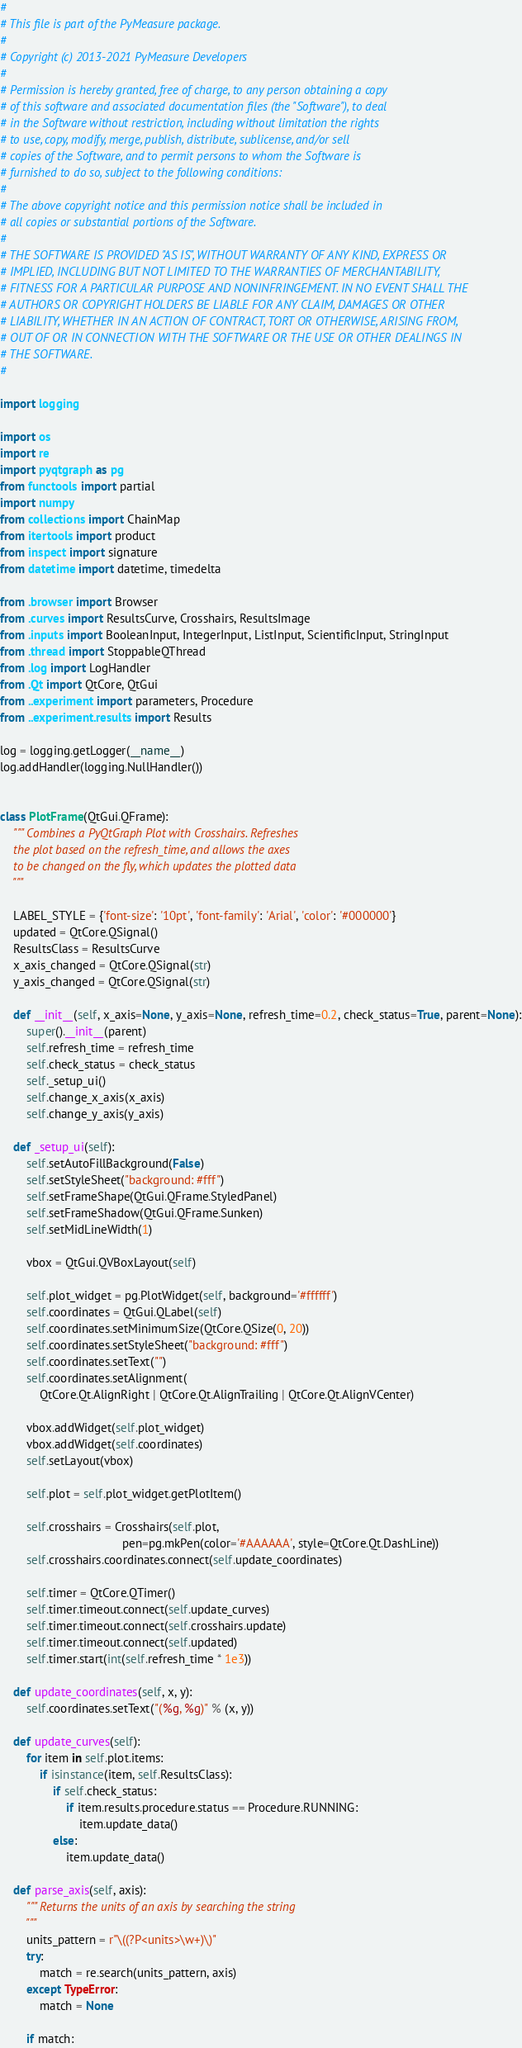Convert code to text. <code><loc_0><loc_0><loc_500><loc_500><_Python_>#
# This file is part of the PyMeasure package.
#
# Copyright (c) 2013-2021 PyMeasure Developers
#
# Permission is hereby granted, free of charge, to any person obtaining a copy
# of this software and associated documentation files (the "Software"), to deal
# in the Software without restriction, including without limitation the rights
# to use, copy, modify, merge, publish, distribute, sublicense, and/or sell
# copies of the Software, and to permit persons to whom the Software is
# furnished to do so, subject to the following conditions:
#
# The above copyright notice and this permission notice shall be included in
# all copies or substantial portions of the Software.
#
# THE SOFTWARE IS PROVIDED "AS IS", WITHOUT WARRANTY OF ANY KIND, EXPRESS OR
# IMPLIED, INCLUDING BUT NOT LIMITED TO THE WARRANTIES OF MERCHANTABILITY,
# FITNESS FOR A PARTICULAR PURPOSE AND NONINFRINGEMENT. IN NO EVENT SHALL THE
# AUTHORS OR COPYRIGHT HOLDERS BE LIABLE FOR ANY CLAIM, DAMAGES OR OTHER
# LIABILITY, WHETHER IN AN ACTION OF CONTRACT, TORT OR OTHERWISE, ARISING FROM,
# OUT OF OR IN CONNECTION WITH THE SOFTWARE OR THE USE OR OTHER DEALINGS IN
# THE SOFTWARE.
#

import logging

import os
import re
import pyqtgraph as pg
from functools import partial
import numpy
from collections import ChainMap
from itertools import product
from inspect import signature
from datetime import datetime, timedelta

from .browser import Browser
from .curves import ResultsCurve, Crosshairs, ResultsImage
from .inputs import BooleanInput, IntegerInput, ListInput, ScientificInput, StringInput
from .thread import StoppableQThread
from .log import LogHandler
from .Qt import QtCore, QtGui
from ..experiment import parameters, Procedure
from ..experiment.results import Results

log = logging.getLogger(__name__)
log.addHandler(logging.NullHandler())


class PlotFrame(QtGui.QFrame):
    """ Combines a PyQtGraph Plot with Crosshairs. Refreshes
    the plot based on the refresh_time, and allows the axes
    to be changed on the fly, which updates the plotted data
    """

    LABEL_STYLE = {'font-size': '10pt', 'font-family': 'Arial', 'color': '#000000'}
    updated = QtCore.QSignal()
    ResultsClass = ResultsCurve
    x_axis_changed = QtCore.QSignal(str)
    y_axis_changed = QtCore.QSignal(str)

    def __init__(self, x_axis=None, y_axis=None, refresh_time=0.2, check_status=True, parent=None):
        super().__init__(parent)
        self.refresh_time = refresh_time
        self.check_status = check_status
        self._setup_ui()
        self.change_x_axis(x_axis)
        self.change_y_axis(y_axis)

    def _setup_ui(self):
        self.setAutoFillBackground(False)
        self.setStyleSheet("background: #fff")
        self.setFrameShape(QtGui.QFrame.StyledPanel)
        self.setFrameShadow(QtGui.QFrame.Sunken)
        self.setMidLineWidth(1)

        vbox = QtGui.QVBoxLayout(self)

        self.plot_widget = pg.PlotWidget(self, background='#ffffff')
        self.coordinates = QtGui.QLabel(self)
        self.coordinates.setMinimumSize(QtCore.QSize(0, 20))
        self.coordinates.setStyleSheet("background: #fff")
        self.coordinates.setText("")
        self.coordinates.setAlignment(
            QtCore.Qt.AlignRight | QtCore.Qt.AlignTrailing | QtCore.Qt.AlignVCenter)

        vbox.addWidget(self.plot_widget)
        vbox.addWidget(self.coordinates)
        self.setLayout(vbox)

        self.plot = self.plot_widget.getPlotItem()

        self.crosshairs = Crosshairs(self.plot,
                                     pen=pg.mkPen(color='#AAAAAA', style=QtCore.Qt.DashLine))
        self.crosshairs.coordinates.connect(self.update_coordinates)

        self.timer = QtCore.QTimer()
        self.timer.timeout.connect(self.update_curves)
        self.timer.timeout.connect(self.crosshairs.update)
        self.timer.timeout.connect(self.updated)
        self.timer.start(int(self.refresh_time * 1e3))

    def update_coordinates(self, x, y):
        self.coordinates.setText("(%g, %g)" % (x, y))

    def update_curves(self):
        for item in self.plot.items:
            if isinstance(item, self.ResultsClass):
                if self.check_status:
                    if item.results.procedure.status == Procedure.RUNNING:
                        item.update_data()
                else:
                    item.update_data()

    def parse_axis(self, axis):
        """ Returns the units of an axis by searching the string
        """
        units_pattern = r"\((?P<units>\w+)\)"
        try:
            match = re.search(units_pattern, axis)
        except TypeError:
            match = None

        if match:</code> 